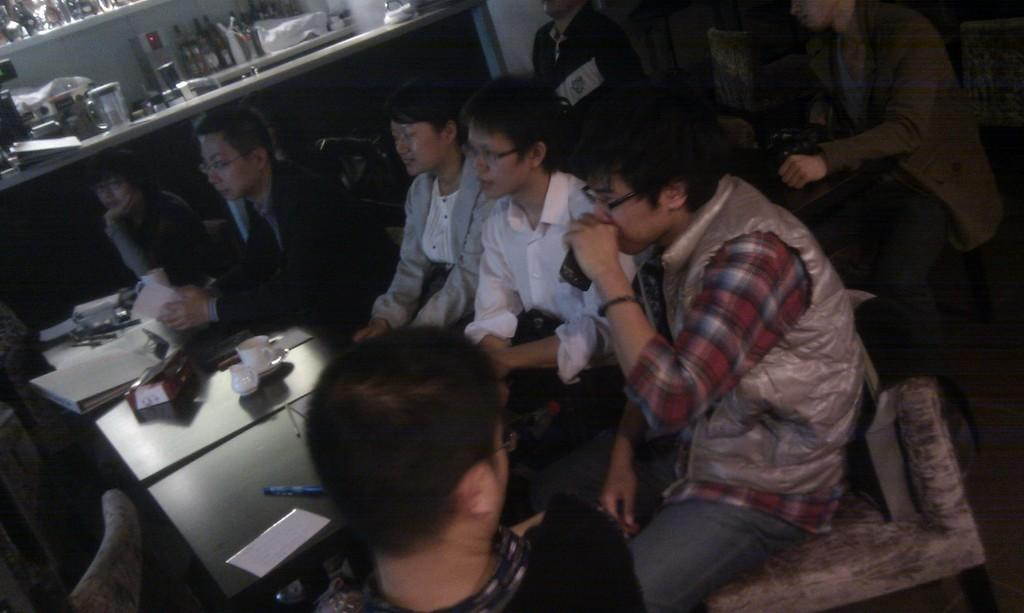What are the persons in the image doing? The persons in the image are sitting. What is in front of the sitting persons? There is a table in front of the sitting persons. What can be seen on the table? There are objects on the table. Can you describe the people behind the sitting persons? There are other people behind the sitting persons. What type of music is the band playing in the image? There is no band present in the image, so it is not possible to determine what, if any, music might be playing. 